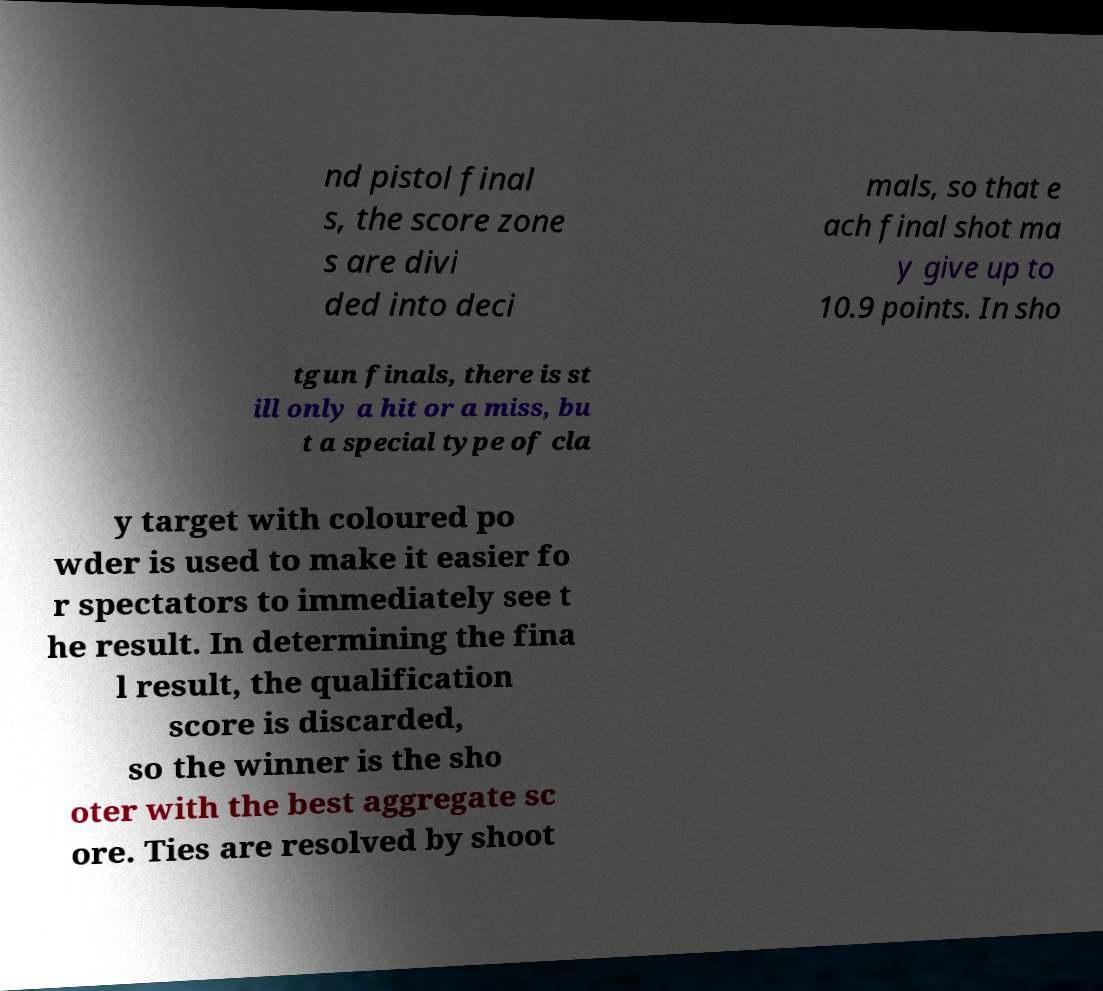Please read and relay the text visible in this image. What does it say? nd pistol final s, the score zone s are divi ded into deci mals, so that e ach final shot ma y give up to 10.9 points. In sho tgun finals, there is st ill only a hit or a miss, bu t a special type of cla y target with coloured po wder is used to make it easier fo r spectators to immediately see t he result. In determining the fina l result, the qualification score is discarded, so the winner is the sho oter with the best aggregate sc ore. Ties are resolved by shoot 